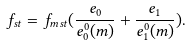<formula> <loc_0><loc_0><loc_500><loc_500>f _ { s t } = f _ { m s t } ( \frac { e _ { 0 } } { e _ { 0 } ^ { 0 } ( m ) } + \frac { e _ { 1 } } { e _ { 1 } ^ { 0 } ( m ) } ) .</formula> 